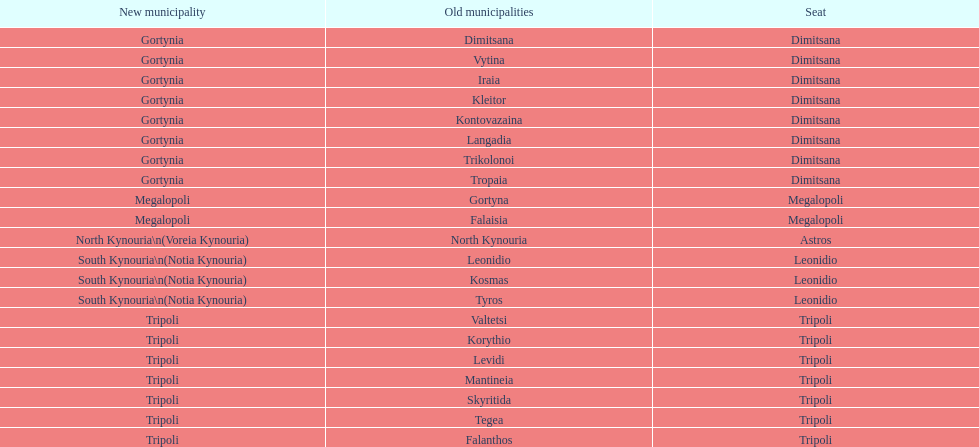After the 2011 reorganization, does tripoli continue to be a municipality in arcadia? Yes. 